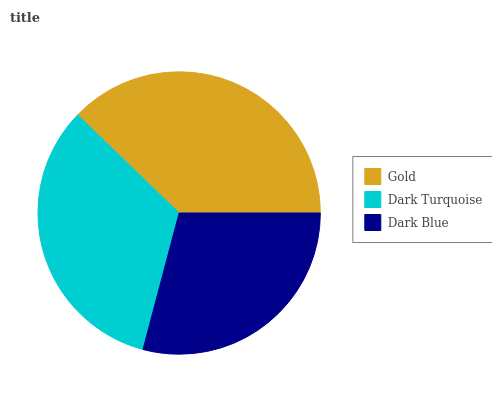Is Dark Blue the minimum?
Answer yes or no. Yes. Is Gold the maximum?
Answer yes or no. Yes. Is Dark Turquoise the minimum?
Answer yes or no. No. Is Dark Turquoise the maximum?
Answer yes or no. No. Is Gold greater than Dark Turquoise?
Answer yes or no. Yes. Is Dark Turquoise less than Gold?
Answer yes or no. Yes. Is Dark Turquoise greater than Gold?
Answer yes or no. No. Is Gold less than Dark Turquoise?
Answer yes or no. No. Is Dark Turquoise the high median?
Answer yes or no. Yes. Is Dark Turquoise the low median?
Answer yes or no. Yes. Is Gold the high median?
Answer yes or no. No. Is Gold the low median?
Answer yes or no. No. 